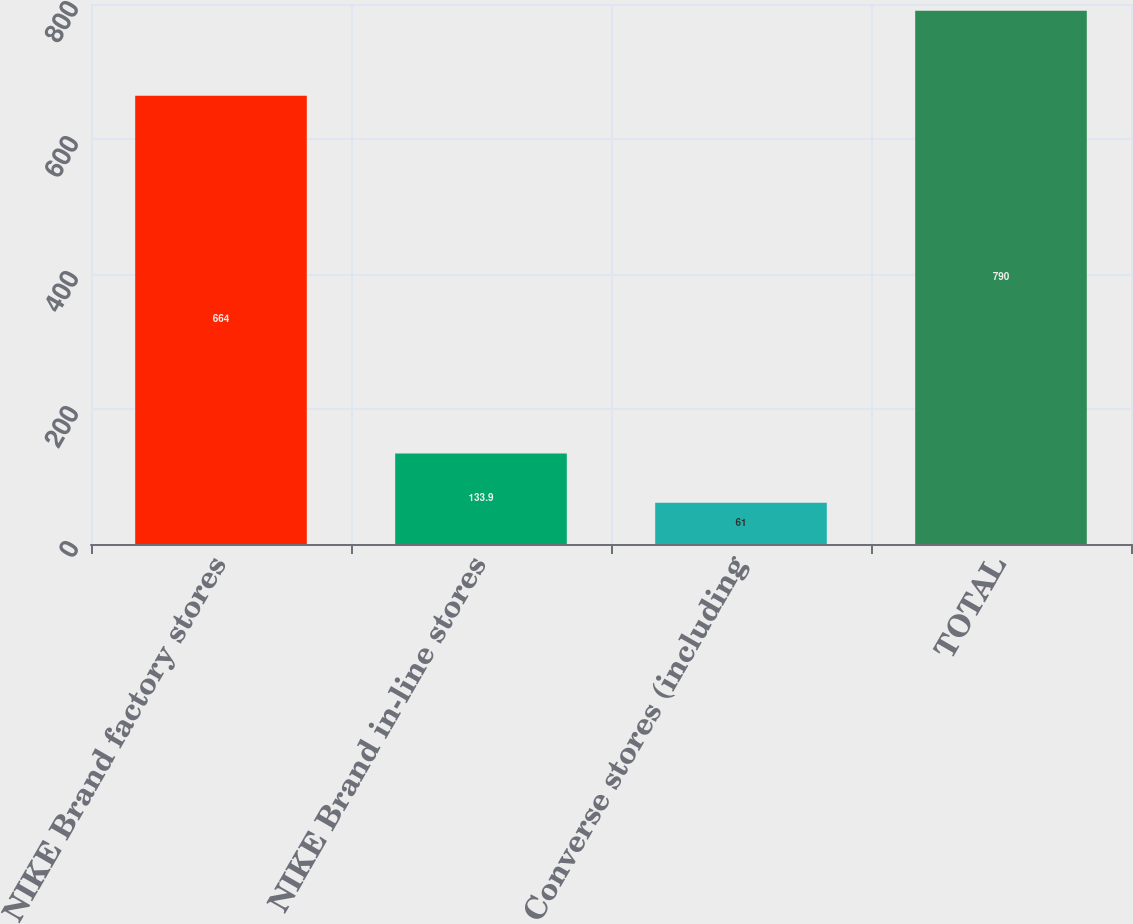<chart> <loc_0><loc_0><loc_500><loc_500><bar_chart><fcel>NIKE Brand factory stores<fcel>NIKE Brand in-line stores<fcel>Converse stores (including<fcel>TOTAL<nl><fcel>664<fcel>133.9<fcel>61<fcel>790<nl></chart> 